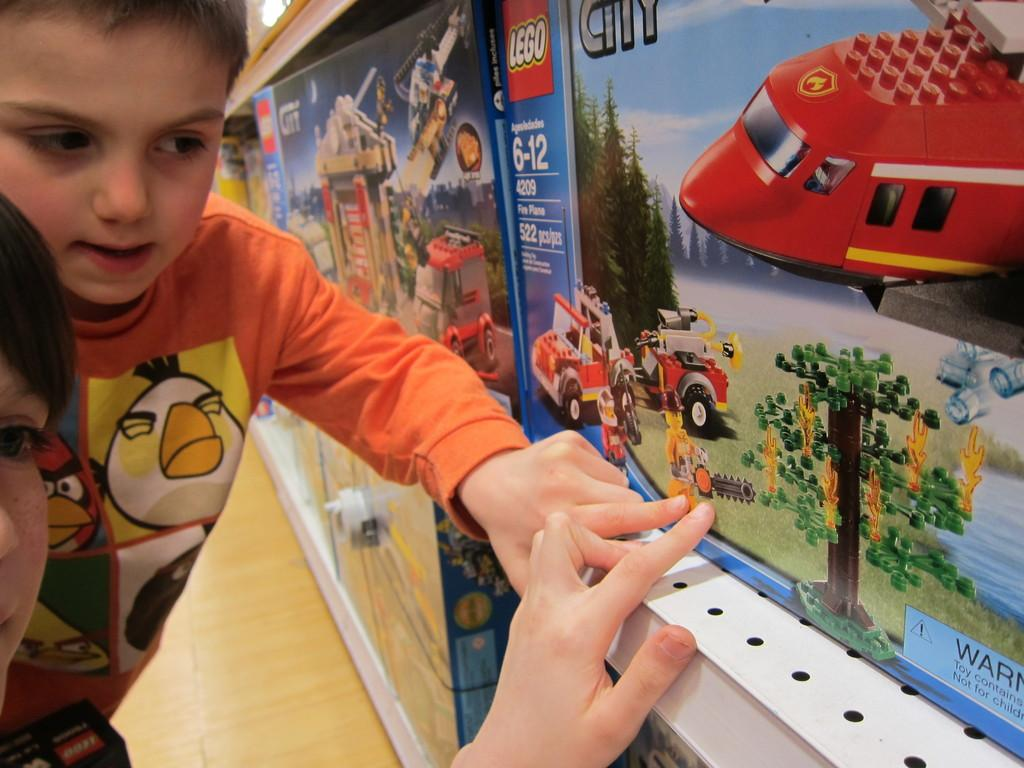<image>
Provide a brief description of the given image. Two kids touch a box for a Lego City helicopter. 